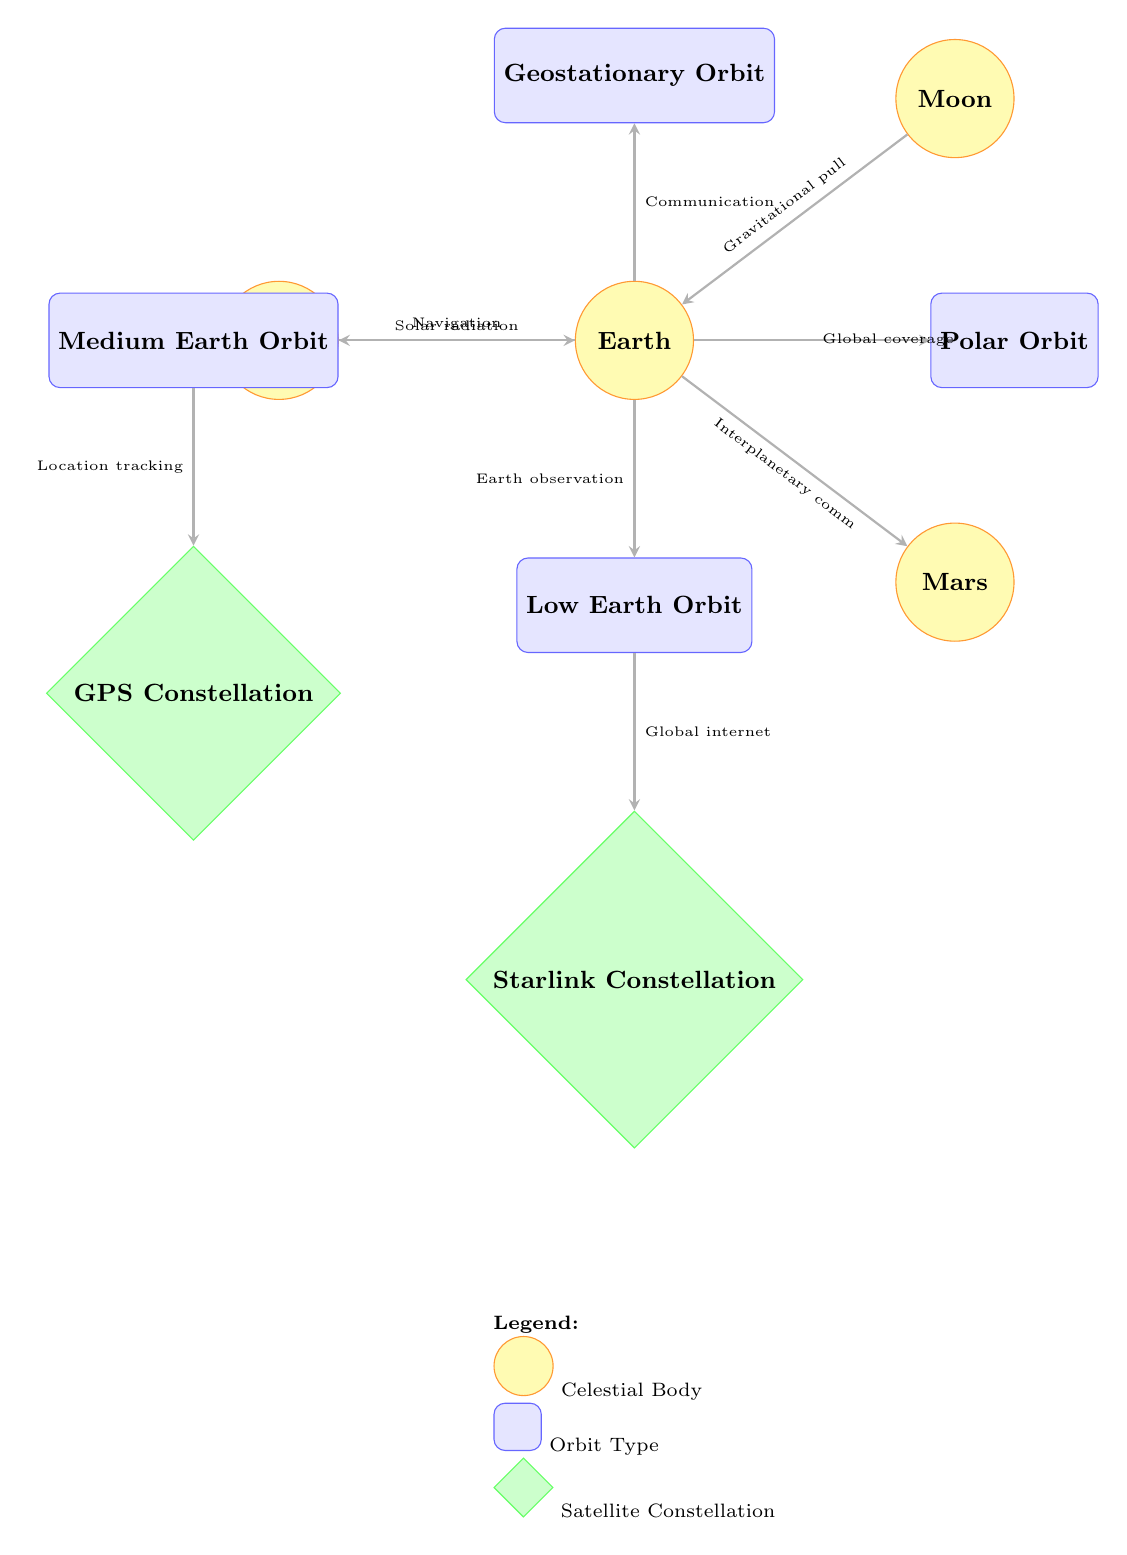What is the closest celestial body to Earth in this diagram? The diagram shows Earth as the central node with the Moon depicted above it. The closest celestial body to Earth is thus the Moon.
Answer: Moon How many different orbit types are illustrated in the diagram? The diagram features four distinct orbit types: Geostationary Orbit, Low Earth Orbit, Medium Earth Orbit, and Polar Orbit. By counting these nodes, we confirm there are four types.
Answer: 4 What connection type is represented between Earth and the Sun? The link between Earth and the Sun is labeled as 'Solar radiation'. This connection indicates the influence of solar energy on Earth, as illustrated in the diagram.
Answer: Solar radiation Which satellite constellation is associated with Low Earth Orbit? The diagram shows that the Starlink Constellation is linked to Low Earth Orbit, indicating its function of providing global internet services from that orbital path.
Answer: Starlink Constellation What type of orbit is used primarily for navigation according to the diagram? The diagram indicates that Navigation is related to Medium Earth Orbit. This orbit type is typically used for satellite navigation systems, like GPS.
Answer: Medium Earth Orbit How many nodes are displayed in total in the diagram? By counting all the celestial bodies, orbits, and constellations in the diagram, we find a total of eight nodes. This includes the Sun, Earth, Moon, Mars, and four orbit types.
Answer: 8 What type of connection does the Earth have with Mars? The connection depicted between Earth and Mars is labeled 'Interplanetary comm', indicating the purpose of communication links that may exist for exploration or research.
Answer: Interplanetary comm Which orbit provides global coverage as shown in the diagram? According to the diagram, the Polar Orbit is the one that links to 'Global coverage', as polar orbits allow satellites to cover the entire Earth's surface over time.
Answer: Polar Orbit 